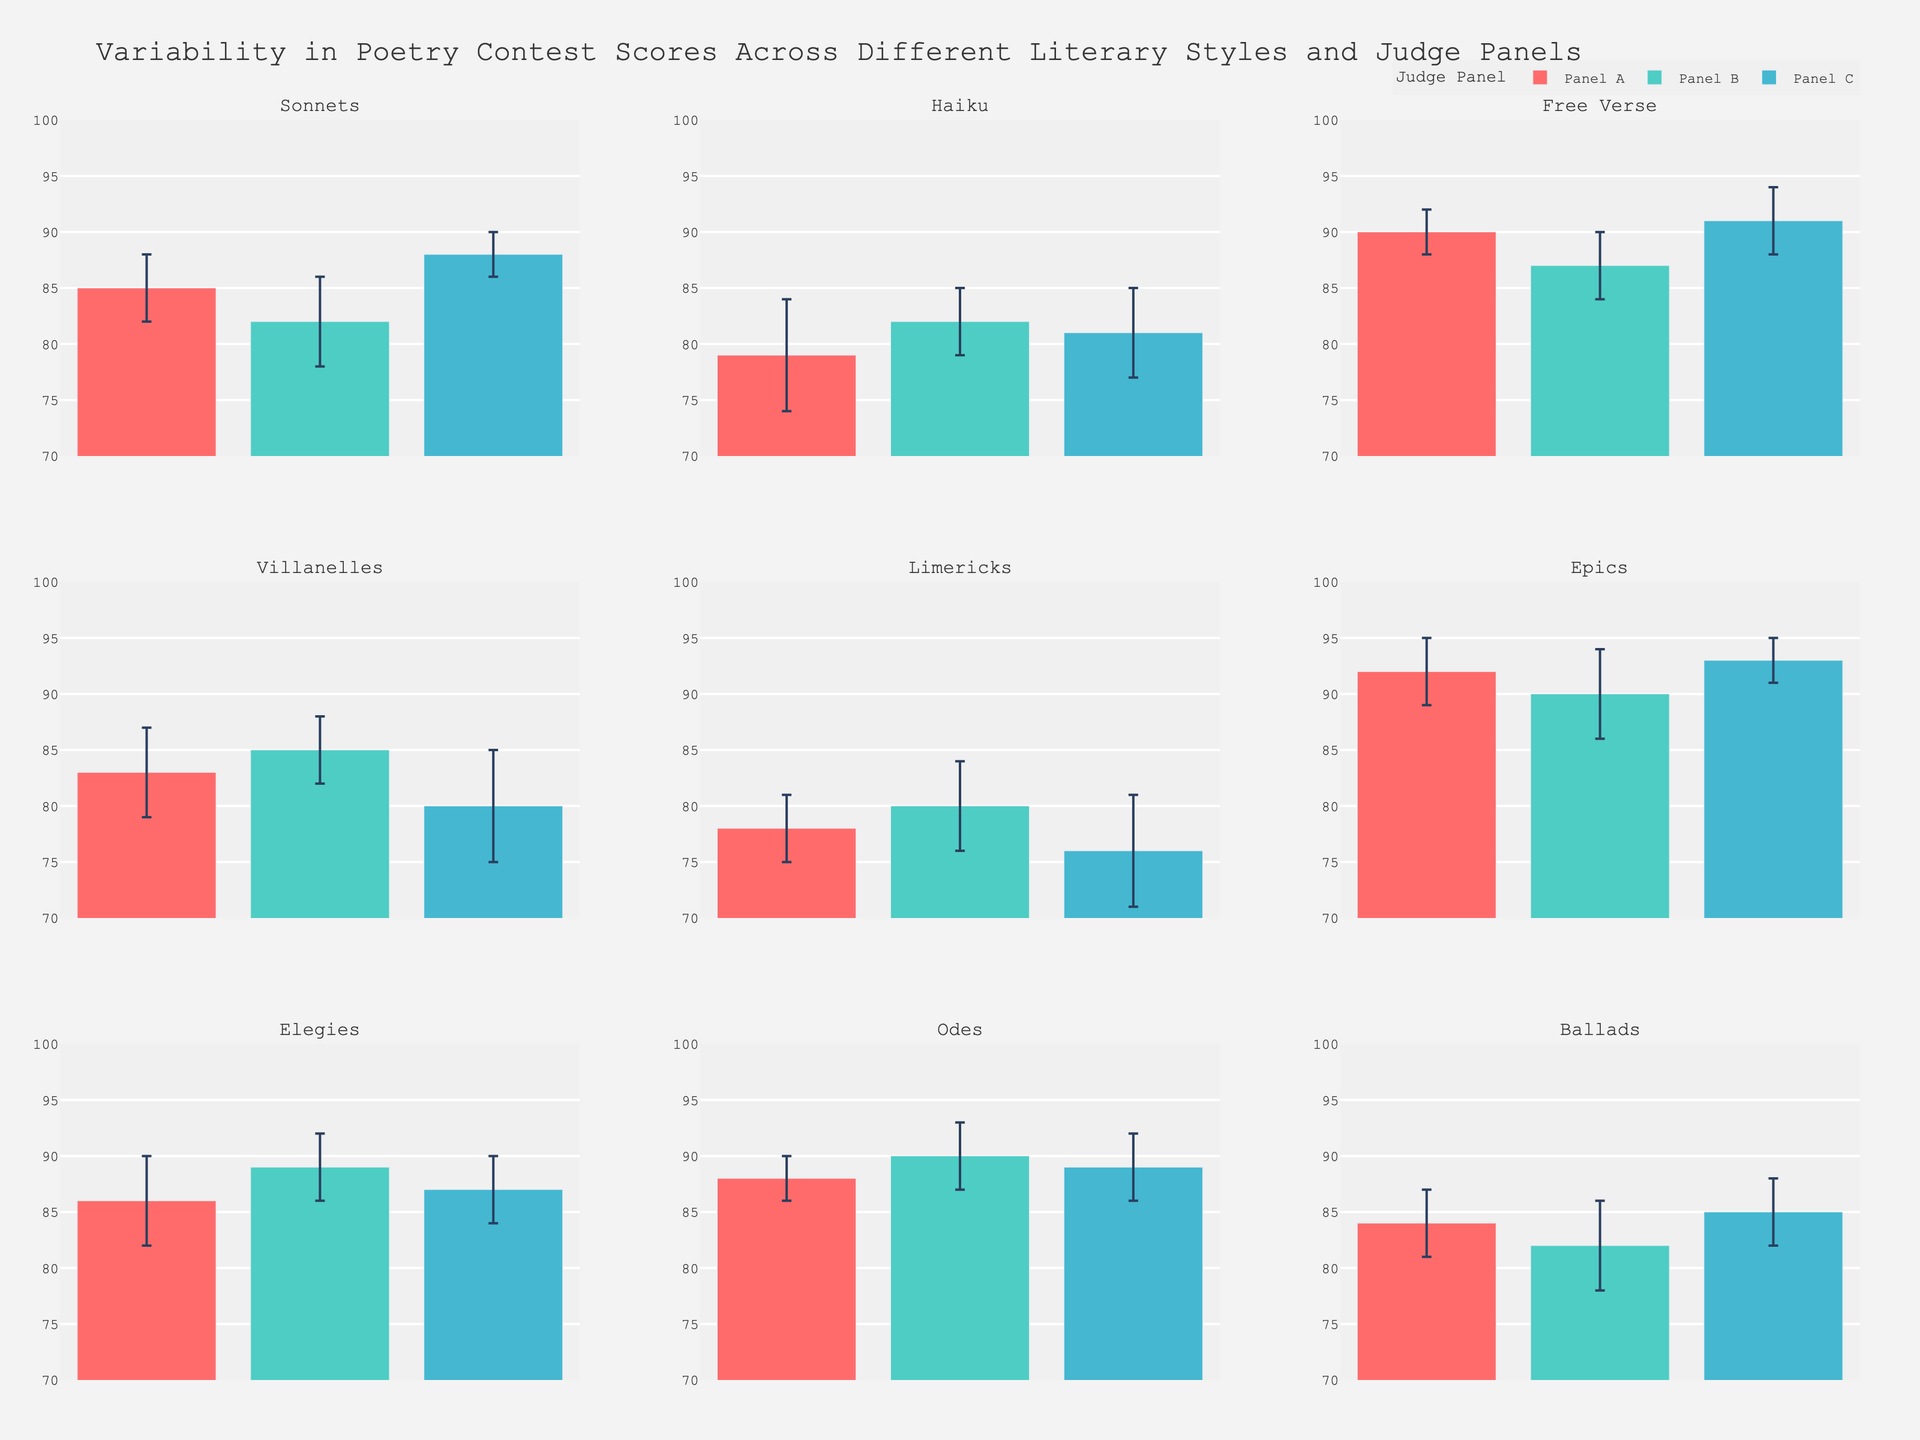Which literary style has the highest score according to Panel A? Look for Panel A scores across different literary styles. The highest score is in the 'Epics' category.
Answer: Epics What's the range of scores given by Panel B for the Limericks? Refer to the subplot for 'Limericks' and check the error bars for Panel B (80 with a deviation range of 80 - 4 to 80 + 4). The range covers from 76 to 84.
Answer: 76 to 84 Which judge panel gave the most consistent scores across all literary styles? By examining the length of the error bars in each subplot, the panel with the shortest ones is the most consistent. Panel C shows the shortest and most consistent error bars overall.
Answer: Panel C How does the average score of the Haiku compare to the average score of the Villanelles across all panels? Calculate the average for both styles by adding the scores and dividing by the number of panels (Haiku: (79 + 82 + 81) / 3; Villanelles: (83 + 85 + 80) / 3). Haiku average = 80.67, Villanelles average = 82.67, so Villanelles have a higher average score.
Answer: Villanelles have a higher average score Which literary style exhibits the greatest variability in scores, as seen through standard deviation values? Look for the style with the largest overall error bars across all subplots, which indicates higher variability. 'Haiku' seems to have the largest error bars on average.
Answer: Haiku What is the score given by Panel C for Free Verse compared to Sonnets? Locate the scores for Free Verse and Sonnets judged by Panel C. Free Verse (91) is higher than Sonnets (88).
Answer: Free Verse has a higher score Among Odes and Elegies, which style received a higher average score from Panel B? Calculate the average score for both styles from Panel B (Odes: 90, Elegies: 89). Odes have the higher average.
Answer: Odes Identify the literary styles where scores from Panel A fall below 85. Look at Panel A scores in each subplot, identifying the ones below 85. These are Haiku, Limericks, and Villanelles.
Answer: Haiku, Limericks, Villanelles How does the scoring consistency of Panel B for Haiku compare to Free Verse? Check the error bars' length for Haiku and Free Verse from Panel B. Haiku has wider error bars, indicating less consistency compared to Free Verse.
Answer: Free Verse is more consistent What trends do you notice in the scoring by Panel C for Epics and Odes? Compare the plotted scores and error bars for both subplots judged by Panel C. Both styles have high scores (93 for Epics, 89 for Odes) with narrow error bars indicating small variability.
Answer: High scores with small variability 